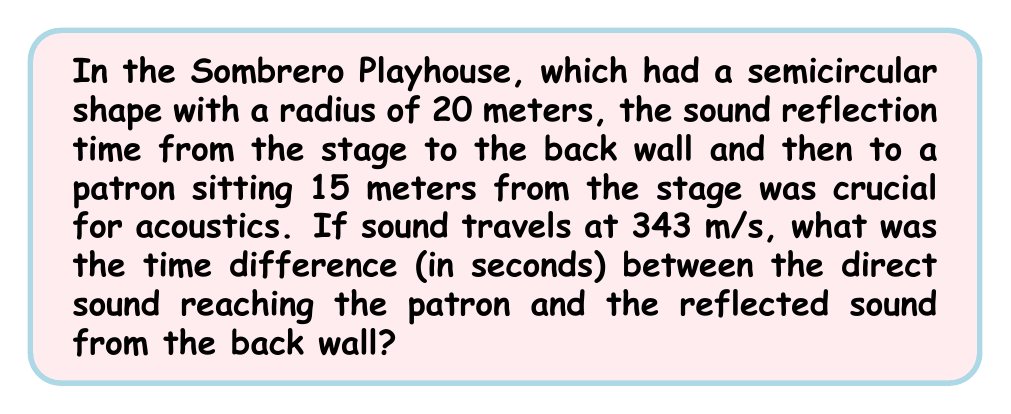Can you answer this question? Let's approach this step-by-step:

1) First, we need to calculate the direct path of the sound:
   Direct path = 15 meters

2) Now, let's calculate the reflected path:
   - Distance from stage to back wall: 20 meters (radius)
   - Distance from back wall to patron: 20 - 15 = 5 meters
   Total reflected path = 20 + 5 = 25 meters

3) We can calculate the time for each path using the formula:
   $t = \frac{d}{v}$, where $t$ is time, $d$ is distance, and $v$ is velocity

4) For the direct path:
   $t_{direct} = \frac{15}{343} \approx 0.0437$ seconds

5) For the reflected path:
   $t_{reflected} = \frac{25}{343} \approx 0.0729$ seconds

6) The time difference is:
   $\Delta t = t_{reflected} - t_{direct}$
   $\Delta t = 0.0729 - 0.0437 = 0.0292$ seconds

Therefore, the time difference between the direct and reflected sound is approximately 0.0292 seconds.
Answer: 0.0292 seconds 